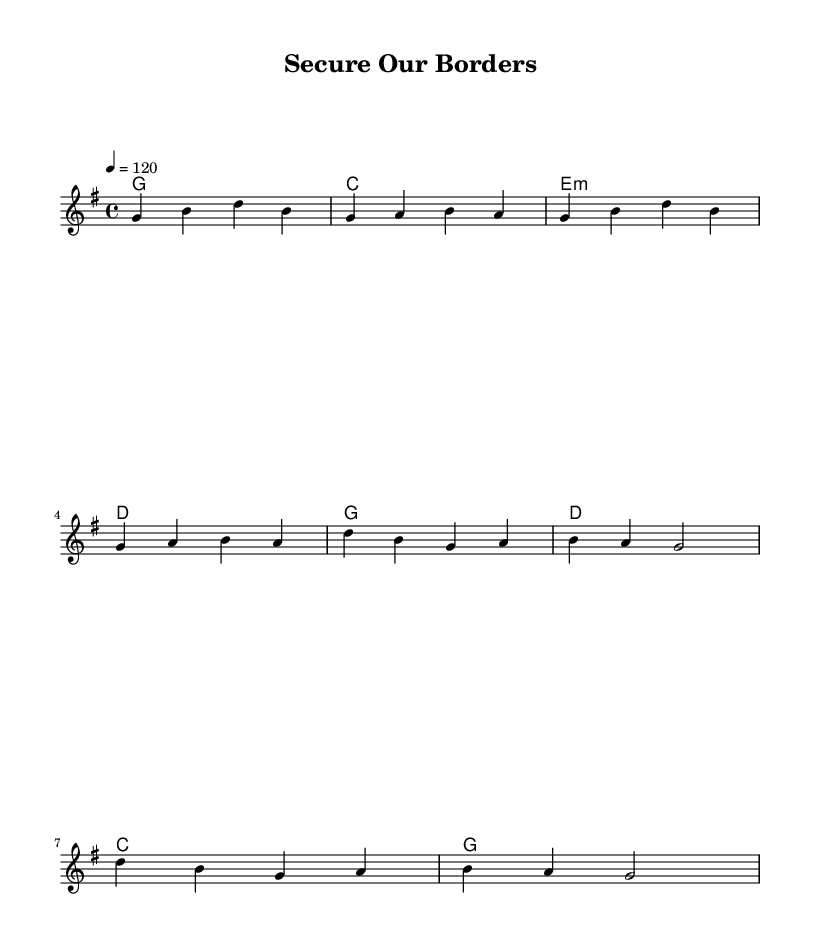What is the key signature of this music? The key signature is G major, indicated by one sharp (F#) which is present on the staff.
Answer: G major What is the time signature for this piece? The time signature is 4/4, which means there are four beats in each measure and a quarter note gets one beat.
Answer: 4/4 What is the tempo marking of this music? The tempo marking is 120, shown in the score which indicates the beats per minute that should be played.
Answer: 120 What kind of lyrical theme is present in this song? The lyrics focus on border security and immigration reform, using a call to action and addressing national pride.
Answer: Border security How many measures are in the verse section? The verse consists of four measures as indicated in the melody section before the chorus starts, mentioned in the chord progressions.
Answer: 4 Which chord is played during the chorus? The chords during the chorus include G, D, C, and back to G, as shown in the harmonies part.
Answer: G, D, C Describe the lyrical structure of the song. The song has a verse followed by a chorus, which is a common structure in country rock songs emphasizing a narrative with a repeated message in the chorus.
Answer: Verse and chorus 